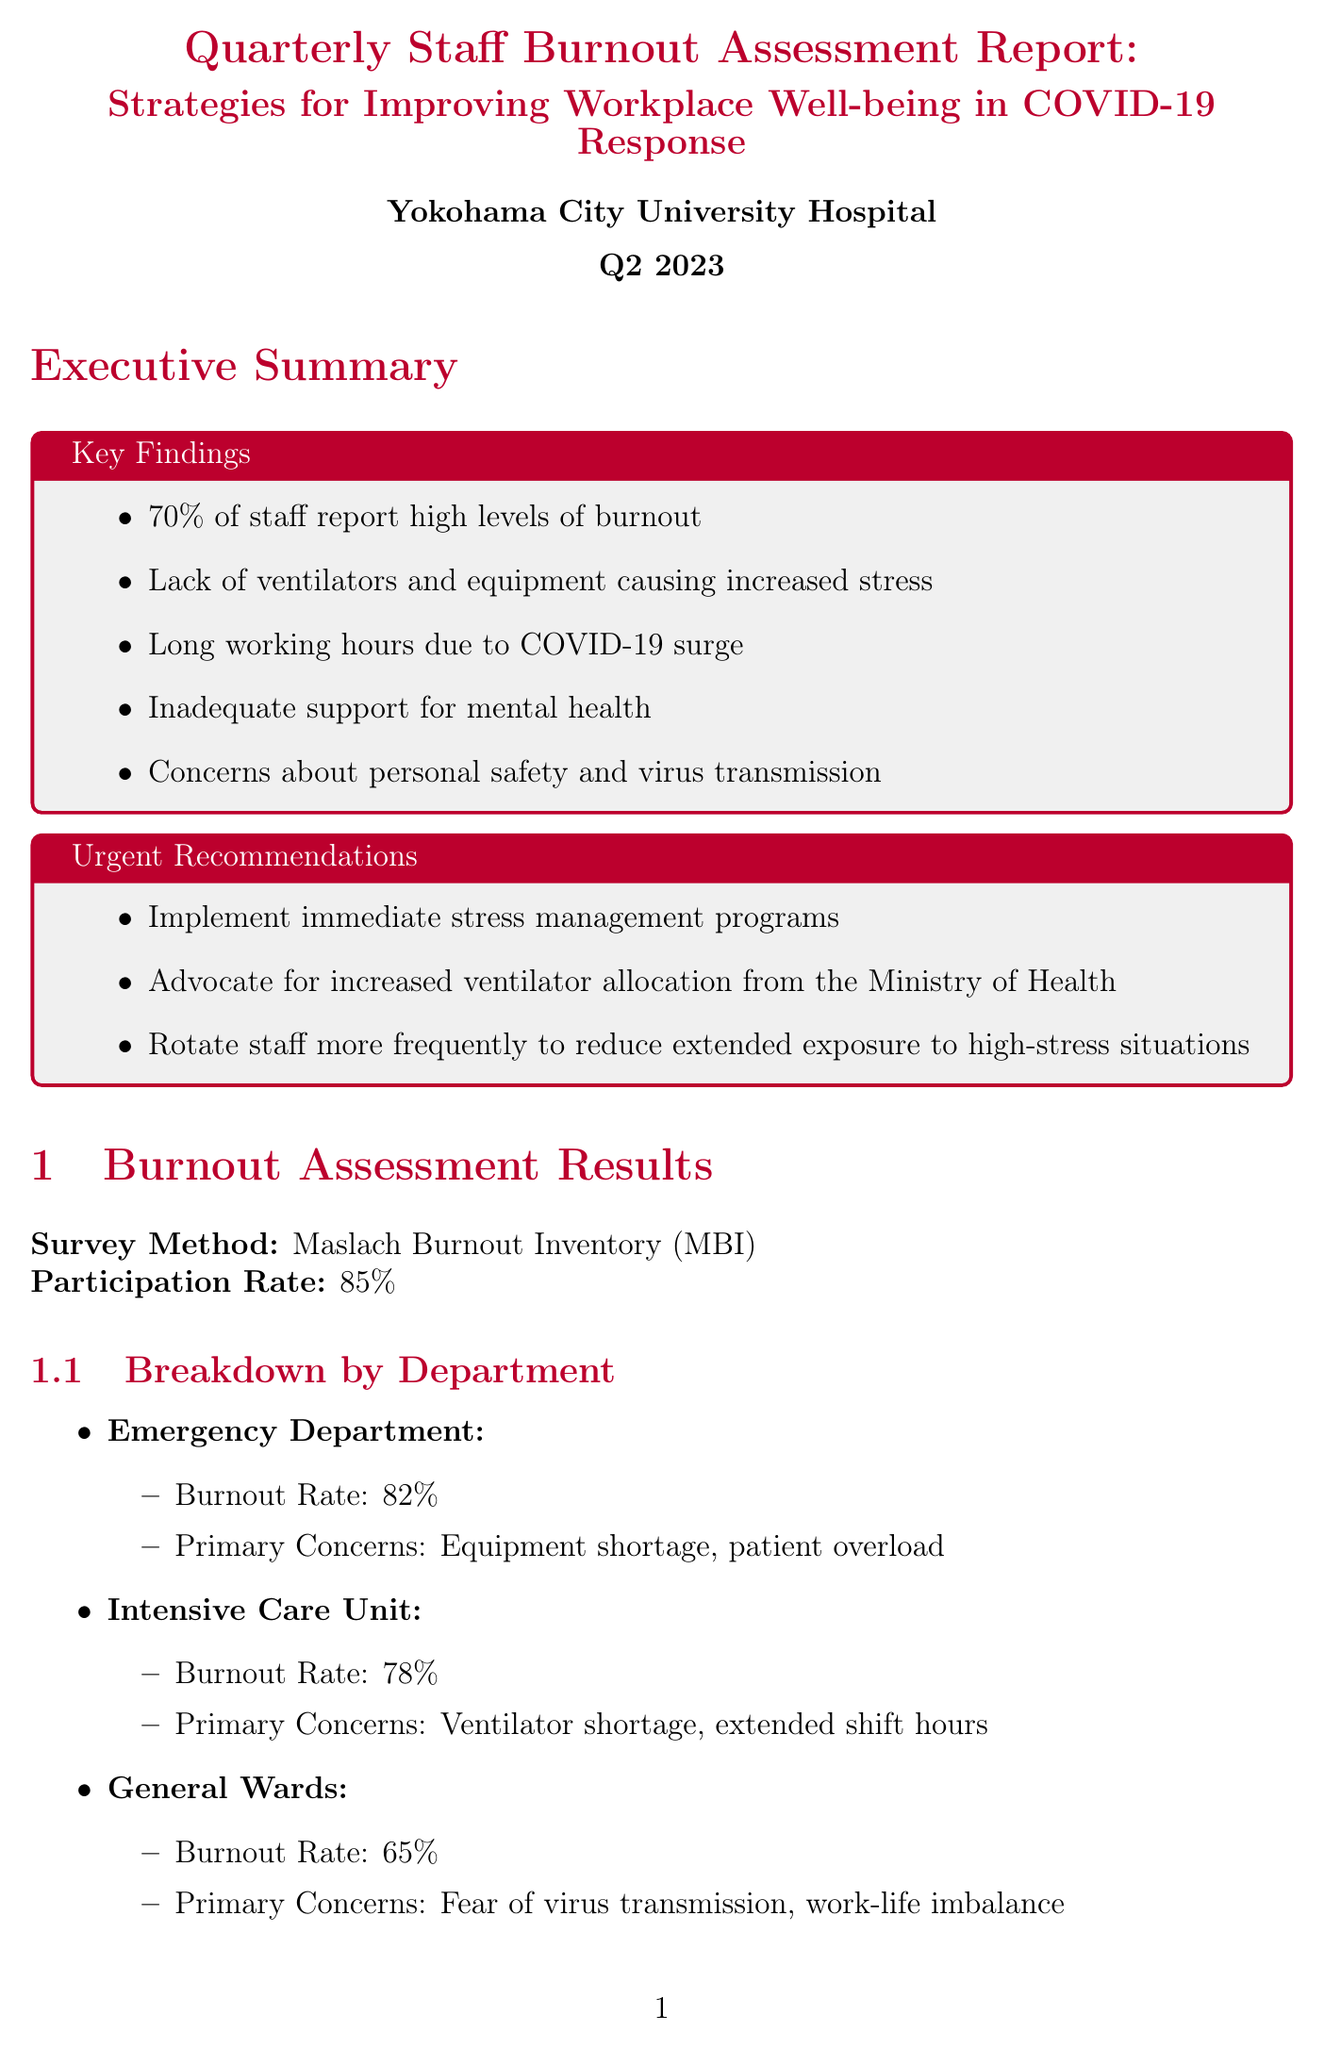What percentage of staff report high levels of burnout? The document states that 70% of staff report high levels of burnout.
Answer: 70% What is the primary concern for the Intensive Care Unit? The report indicates that the primary concern for the ICU is ventilator shortage and extended shift hours.
Answer: Ventilator shortage Who is responsible for implementing the 'No Overtime Day' policy? The responsible party for this policy is Masato Suzuki, the Hospital Administrator.
Answer: Masato Suzuki What is the budget allocated for mental health support? The budget for mental health support as mentioned in the report is ¥5,000,000.
Answer: ¥5,000,000 How often are the peer support group sessions scheduled to occur? The document notes that peer support group sessions will occur on an ongoing weekly basis.
Answer: Weekly What is the target number of additional ventilators mentioned in the resource allocation section? The document targets the acquisition of 10 additional ventilators.
Answer: 10 additional ventilators What long-term goal is set for reducing burnout rates? The long-term goal is to reduce the overall staff burnout rate to below 30% within 12 months.
Answer: Below 30% Which department has the highest burnout rate? The report states that the Emergency Department has the highest burnout rate of 82%.
Answer: Emergency Department 